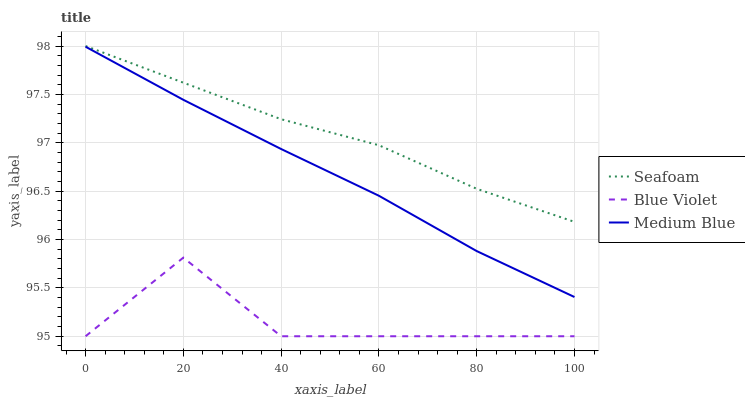Does Blue Violet have the minimum area under the curve?
Answer yes or no. Yes. Does Seafoam have the maximum area under the curve?
Answer yes or no. Yes. Does Seafoam have the minimum area under the curve?
Answer yes or no. No. Does Blue Violet have the maximum area under the curve?
Answer yes or no. No. Is Medium Blue the smoothest?
Answer yes or no. Yes. Is Blue Violet the roughest?
Answer yes or no. Yes. Is Seafoam the smoothest?
Answer yes or no. No. Is Seafoam the roughest?
Answer yes or no. No. Does Blue Violet have the lowest value?
Answer yes or no. Yes. Does Seafoam have the lowest value?
Answer yes or no. No. Does Seafoam have the highest value?
Answer yes or no. Yes. Does Blue Violet have the highest value?
Answer yes or no. No. Is Medium Blue less than Seafoam?
Answer yes or no. Yes. Is Medium Blue greater than Blue Violet?
Answer yes or no. Yes. Does Medium Blue intersect Seafoam?
Answer yes or no. No. 